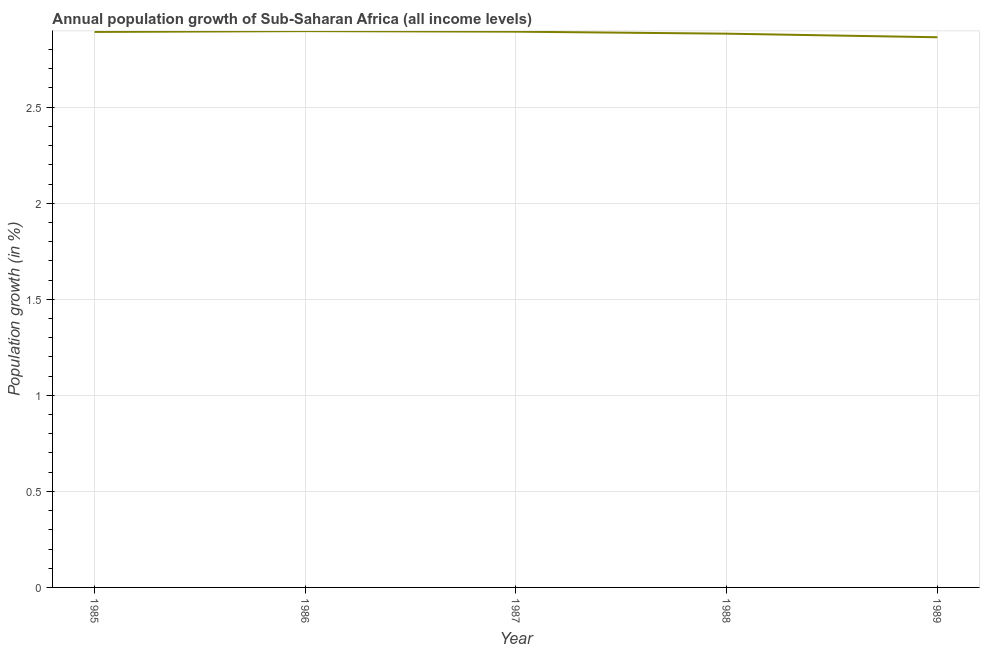What is the population growth in 1986?
Your response must be concise. 2.9. Across all years, what is the maximum population growth?
Ensure brevity in your answer.  2.9. Across all years, what is the minimum population growth?
Keep it short and to the point. 2.86. In which year was the population growth maximum?
Your answer should be very brief. 1986. What is the sum of the population growth?
Your response must be concise. 14.43. What is the difference between the population growth in 1987 and 1989?
Make the answer very short. 0.03. What is the average population growth per year?
Offer a very short reply. 2.89. What is the median population growth?
Your response must be concise. 2.89. Do a majority of the years between 1987 and 1985 (inclusive) have population growth greater than 2.5 %?
Offer a very short reply. No. What is the ratio of the population growth in 1985 to that in 1989?
Keep it short and to the point. 1.01. Is the population growth in 1987 less than that in 1989?
Give a very brief answer. No. Is the difference between the population growth in 1985 and 1987 greater than the difference between any two years?
Your answer should be compact. No. What is the difference between the highest and the second highest population growth?
Your answer should be compact. 0. What is the difference between the highest and the lowest population growth?
Your answer should be compact. 0.03. Does the population growth monotonically increase over the years?
Your answer should be compact. No. What is the difference between two consecutive major ticks on the Y-axis?
Offer a very short reply. 0.5. Does the graph contain any zero values?
Ensure brevity in your answer.  No. Does the graph contain grids?
Your answer should be very brief. Yes. What is the title of the graph?
Ensure brevity in your answer.  Annual population growth of Sub-Saharan Africa (all income levels). What is the label or title of the X-axis?
Your answer should be very brief. Year. What is the label or title of the Y-axis?
Make the answer very short. Population growth (in %). What is the Population growth (in %) of 1985?
Offer a very short reply. 2.89. What is the Population growth (in %) in 1986?
Give a very brief answer. 2.9. What is the Population growth (in %) in 1987?
Offer a very short reply. 2.89. What is the Population growth (in %) in 1988?
Offer a very short reply. 2.88. What is the Population growth (in %) in 1989?
Ensure brevity in your answer.  2.86. What is the difference between the Population growth (in %) in 1985 and 1986?
Offer a terse response. -0. What is the difference between the Population growth (in %) in 1985 and 1987?
Your response must be concise. -0. What is the difference between the Population growth (in %) in 1985 and 1988?
Your answer should be compact. 0.01. What is the difference between the Population growth (in %) in 1985 and 1989?
Keep it short and to the point. 0.03. What is the difference between the Population growth (in %) in 1986 and 1987?
Make the answer very short. 0. What is the difference between the Population growth (in %) in 1986 and 1988?
Give a very brief answer. 0.01. What is the difference between the Population growth (in %) in 1986 and 1989?
Your answer should be very brief. 0.03. What is the difference between the Population growth (in %) in 1987 and 1988?
Provide a succinct answer. 0.01. What is the difference between the Population growth (in %) in 1987 and 1989?
Keep it short and to the point. 0.03. What is the difference between the Population growth (in %) in 1988 and 1989?
Offer a terse response. 0.02. What is the ratio of the Population growth (in %) in 1985 to that in 1986?
Provide a succinct answer. 1. What is the ratio of the Population growth (in %) in 1985 to that in 1988?
Your response must be concise. 1. What is the ratio of the Population growth (in %) in 1985 to that in 1989?
Keep it short and to the point. 1.01. What is the ratio of the Population growth (in %) in 1986 to that in 1987?
Offer a terse response. 1. What is the ratio of the Population growth (in %) in 1987 to that in 1989?
Give a very brief answer. 1.01. What is the ratio of the Population growth (in %) in 1988 to that in 1989?
Offer a very short reply. 1.01. 